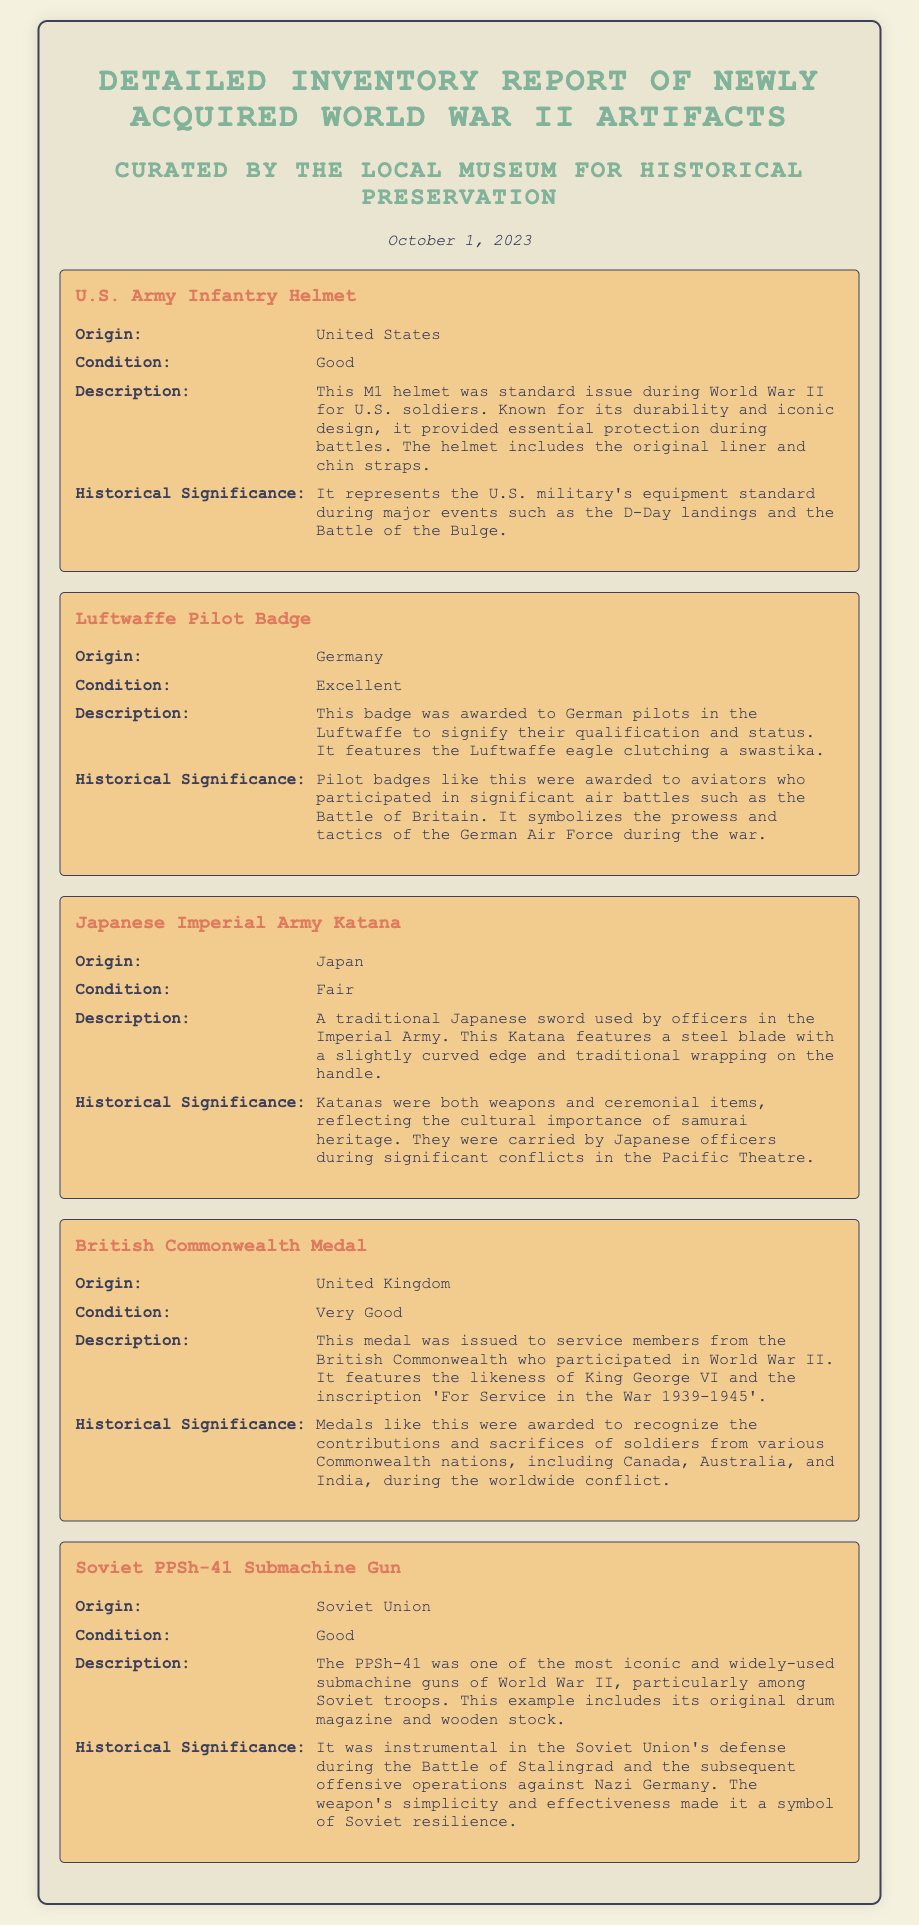What is the origin of the U.S. Army Infantry Helmet? The origin is specified in the artifact details, indicating where it was made or issued.
Answer: United States What is the condition of the Luftwaffe Pilot Badge? The condition is mentioned in the artifact details, describing its physical state.
Answer: Excellent What is the historical significance of the Japanese Imperial Army Katana? The historical significance provides context about its cultural importance and usage during the war.
Answer: Katanas were both weapons and ceremonial items, reflecting the cultural importance of samurai heritage What medal features the likeness of King George VI? The document lists medals and their features, identifying ones by the figures they depict.
Answer: British Commonwealth Medal What is included with the Soviet PPSh-41 Submachine Gun? The details highlight additional components or features associated with each artifact.
Answer: Original drum magazine and wooden stock How many artifacts are listed in the inventory report? This requires counting the distinct artifacts presented in the document to find the total number.
Answer: Five What does the British Commonwealth Medal commemorate? This asks for the purpose or significance outlined for the medal in the document.
Answer: Recognize the contributions and sacrifices of soldiers Which artifact's description mentions D-Day landings? The question seeks to identify which specific artifact is connected to this historical event.
Answer: U.S. Army Infantry Helmet What feature distinguishes the Luftwaffe Pilot Badge? The question focuses on a distinct characteristic highlighted in the description of the badge.
Answer: Luftwaffe eagle clutching a swastika 